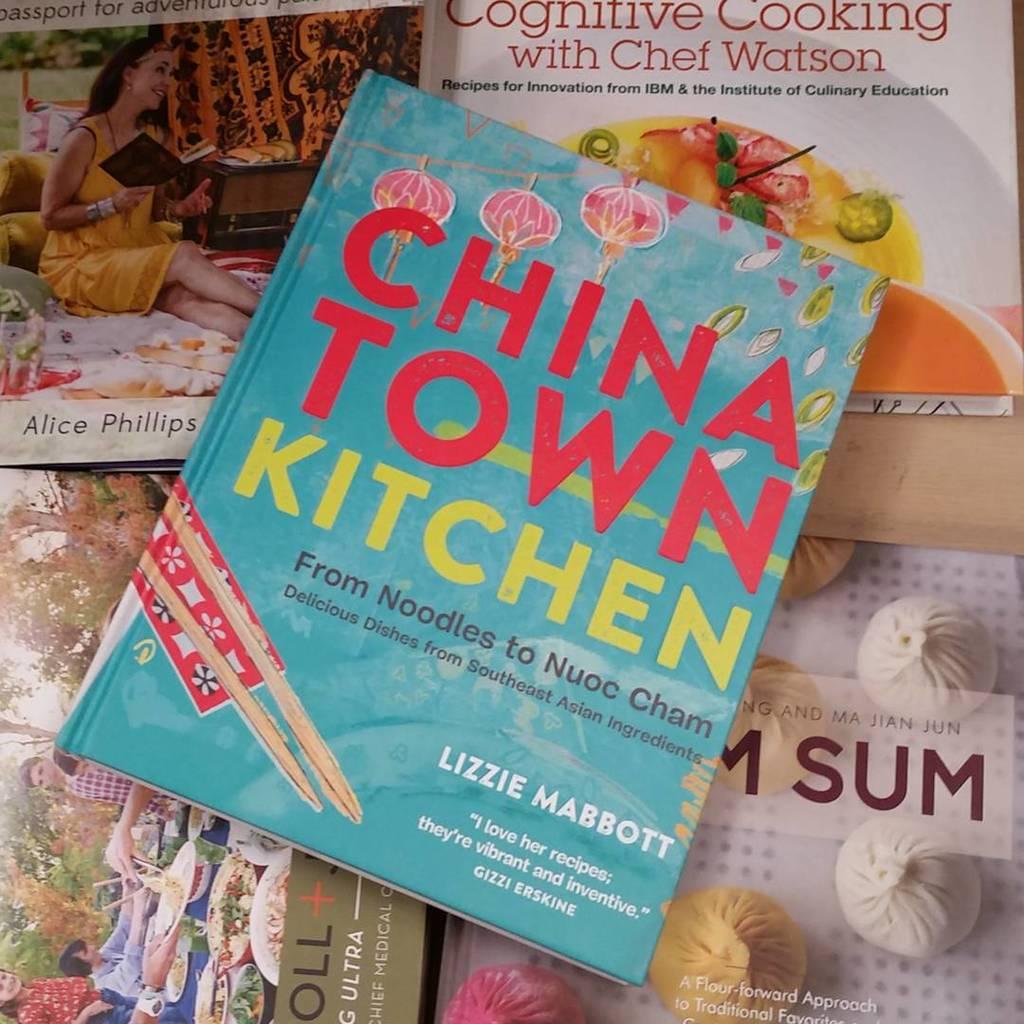<image>
Present a compact description of the photo's key features. A cookbook called China Town Kitchen sits in a pile among other chinese cookbooks 